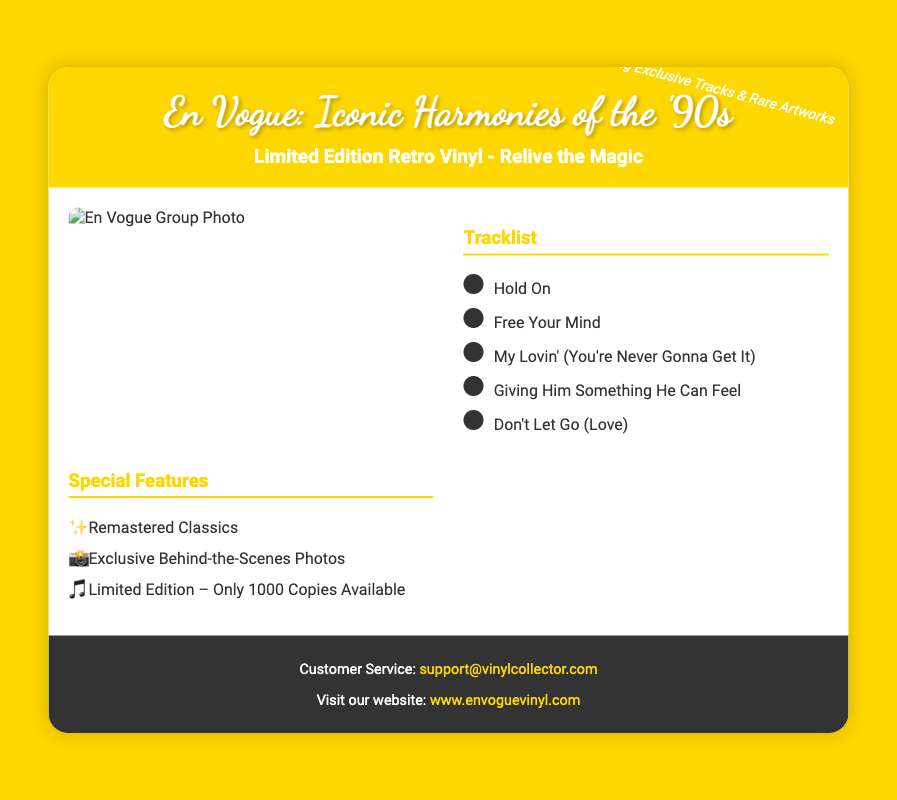What is the title of this limited edition vinyl collection? The title is presented prominently in the header of the document.
Answer: En Vogue: Iconic Harmonies of the '90s How many copies of the vinyl are available? The limited edition specifies the number of copies available in the special features section.
Answer: Only 1000 Copies Available What is the first track listed in the tracklist? The tracklist section provides the order of the songs, with the first one being highlighted.
Answer: Hold On What special feature is mentioned related to the vinyl? The special features section lists unique elements of the collection, including behind-the-scenes content.
Answer: Exclusive Behind-the-Scenes Photos What color is the container's background? The color choice for the container is identified in the styling of the document.
Answer: White Which song includes the phrase "You're Never Gonna Get It"? The tracklist portion of the document includes this specific song title.
Answer: My Lovin' (You're Never Gonna Get It) What is the color of the header text? The header's text color is specified in the document, indicative of the design choice.
Answer: White What is the email address for customer service? The footer provides contact details for customer service, including the email.
Answer: support@vinylcollector.com What type of design is the vinyl cover? The document specifically refers to the design style as part of the collection's appeal.
Answer: Retro Vinyl 